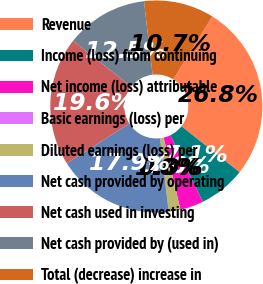Convert chart to OTSL. <chart><loc_0><loc_0><loc_500><loc_500><pie_chart><fcel>Revenue<fcel>Income (loss) from continuing<fcel>Net income (loss) attributable<fcel>Basic earnings (loss) per<fcel>Diluted earnings (loss) per<fcel>Net cash provided by operating<fcel>Net cash used in investing<fcel>Net cash provided by (used in)<fcel>Total (decrease) increase in<nl><fcel>26.79%<fcel>7.14%<fcel>3.57%<fcel>0.0%<fcel>1.79%<fcel>17.86%<fcel>19.64%<fcel>12.5%<fcel>10.71%<nl></chart> 